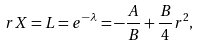<formula> <loc_0><loc_0><loc_500><loc_500>r X = L = e ^ { - \lambda } = - \frac { A } { B } + \frac { B } { 4 } r ^ { 2 } ,</formula> 